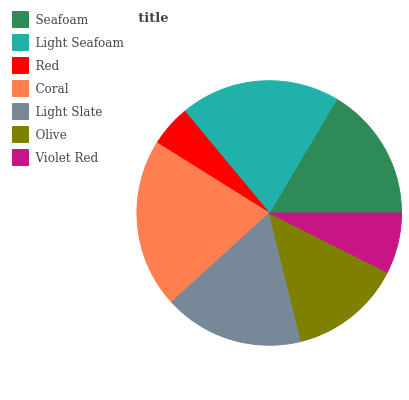Is Red the minimum?
Answer yes or no. Yes. Is Coral the maximum?
Answer yes or no. Yes. Is Light Seafoam the minimum?
Answer yes or no. No. Is Light Seafoam the maximum?
Answer yes or no. No. Is Light Seafoam greater than Seafoam?
Answer yes or no. Yes. Is Seafoam less than Light Seafoam?
Answer yes or no. Yes. Is Seafoam greater than Light Seafoam?
Answer yes or no. No. Is Light Seafoam less than Seafoam?
Answer yes or no. No. Is Seafoam the high median?
Answer yes or no. Yes. Is Seafoam the low median?
Answer yes or no. Yes. Is Light Slate the high median?
Answer yes or no. No. Is Violet Red the low median?
Answer yes or no. No. 